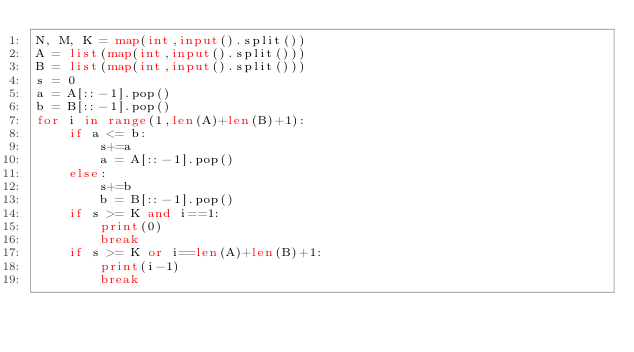Convert code to text. <code><loc_0><loc_0><loc_500><loc_500><_Python_>N, M, K = map(int,input().split())
A = list(map(int,input().split()))
B = list(map(int,input().split()))
s = 0
a = A[::-1].pop()
b = B[::-1].pop()
for i in range(1,len(A)+len(B)+1):
    if a <= b:
        s+=a
        a = A[::-1].pop()
    else:
        s+=b
        b = B[::-1].pop()
    if s >= K and i==1:
        print(0)
        break
    if s >= K or i==len(A)+len(B)+1:
        print(i-1)
        break</code> 